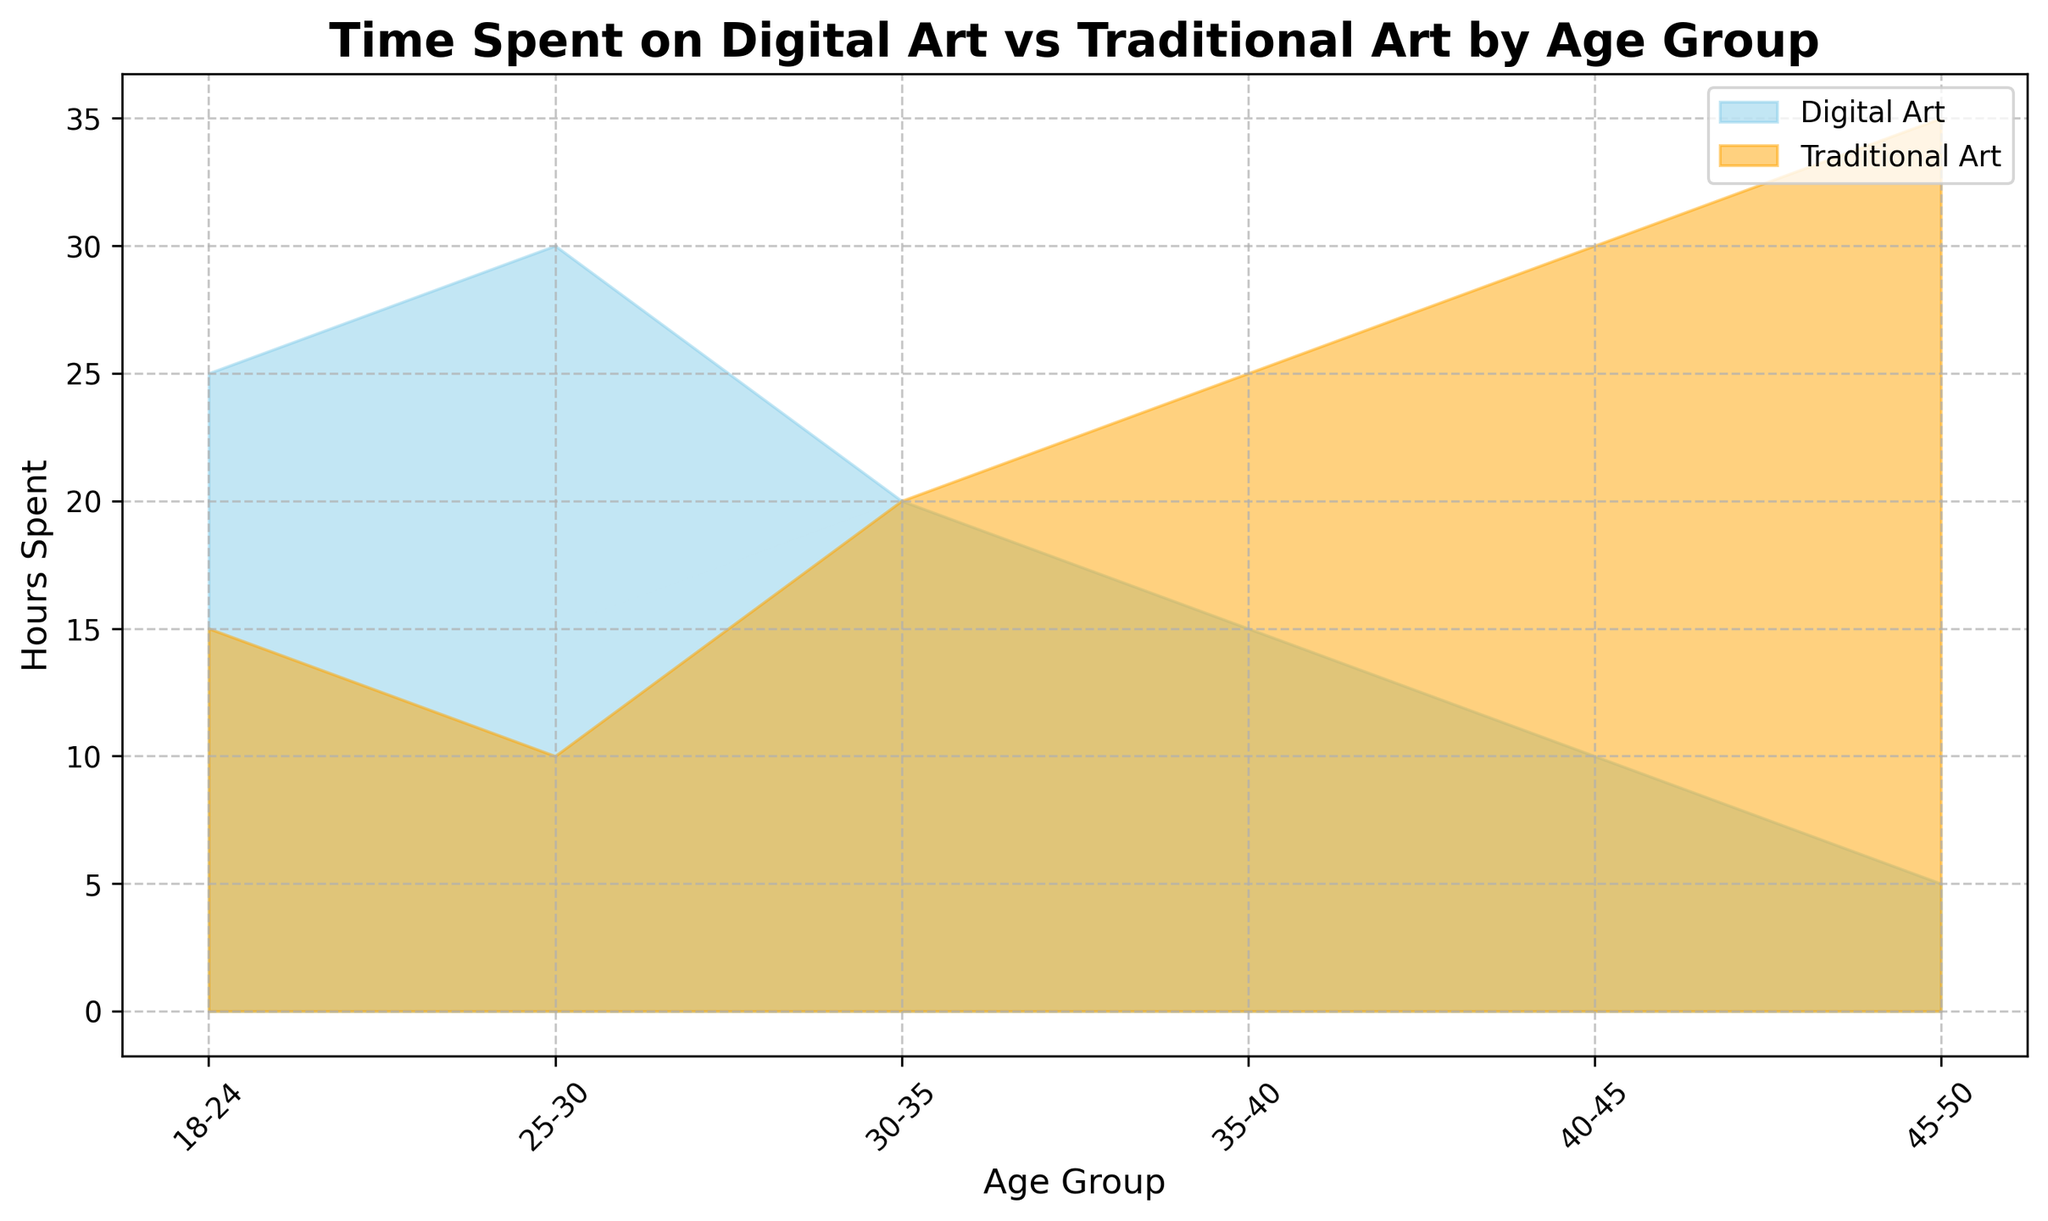What age group spends the most time on digital art? Look at the height of the blue area in the chart. The age group 25-30 has the highest digital art hours with 30 hours.
Answer: 25-30 What age group spends an equal amount of time on digital art and traditional art? Find the sections where the blue and orange areas overlap perfectly. For age group 30-35, both digital art and traditional art have 20 hours each.
Answer: 30-35 Comparing age group 18-24 and 45-50, which group spends more time on traditional art? Compare the height of the orange areas. Age group 45-50 spends 35 hours on traditional art, while age group 18-24 spends 15 hours.
Answer: 45-50 How much more time do artists aged 40-45 spend on traditional art compared to digital art? Calculate the difference in heights for age group 40-45. Traditional art is 30 hours, and digital art is 10 hours. Difference = 30 - 10 = 20 hours.
Answer: 20 hours Which age group spends the least time on digital art? Identify the shortest blue section. Age group 45-50 spends the least time on digital art with 5 hours.
Answer: 45-50 Is there any age group where artists spend more time on digital art than traditional art? Compare the heights of blue and orange sections for each group. Age groups 18-24, 25-30, and 30-35 spend more time on digital art.
Answer: Yes, 18-24, 25-30, 30-35 What is the total number of hours spent on traditional art by artists aged 18-35? Sum the traditional art hours for age groups 18-24, 25-30, and 30-35. Total = 15 + 10 + 20 = 45 hours.
Answer: 45 hours Which age group has the smallest difference in time spent between digital art and traditional art? Calculate the differences for each age group: 
18-24: 25-15 = 10 
25-30: 30-10 = 20 
30-35: 20-20 = 0
35-40: 15-25 = 10 
40-45: 10-30 = 20 
45-50: 5-35 = 30
The smallest difference is 0 for age group 30-35.
Answer: 30-35 